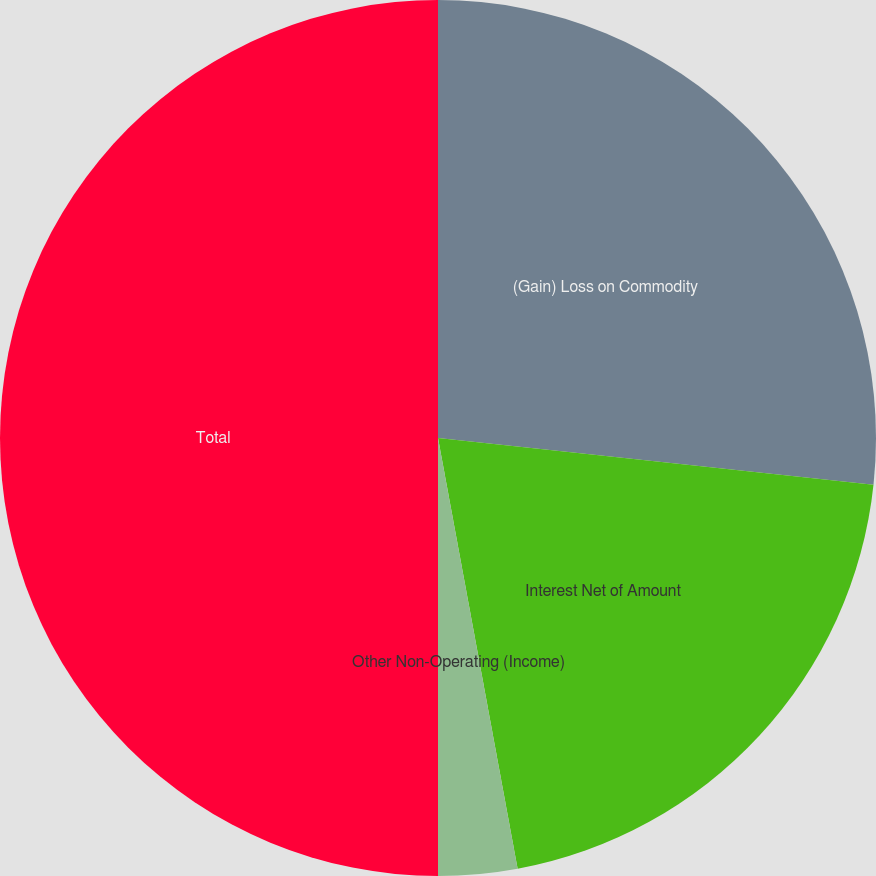Convert chart. <chart><loc_0><loc_0><loc_500><loc_500><pie_chart><fcel>(Gain) Loss on Commodity<fcel>Interest Net of Amount<fcel>Other Non-Operating (Income)<fcel>Total<nl><fcel>26.7%<fcel>20.39%<fcel>2.91%<fcel>50.0%<nl></chart> 